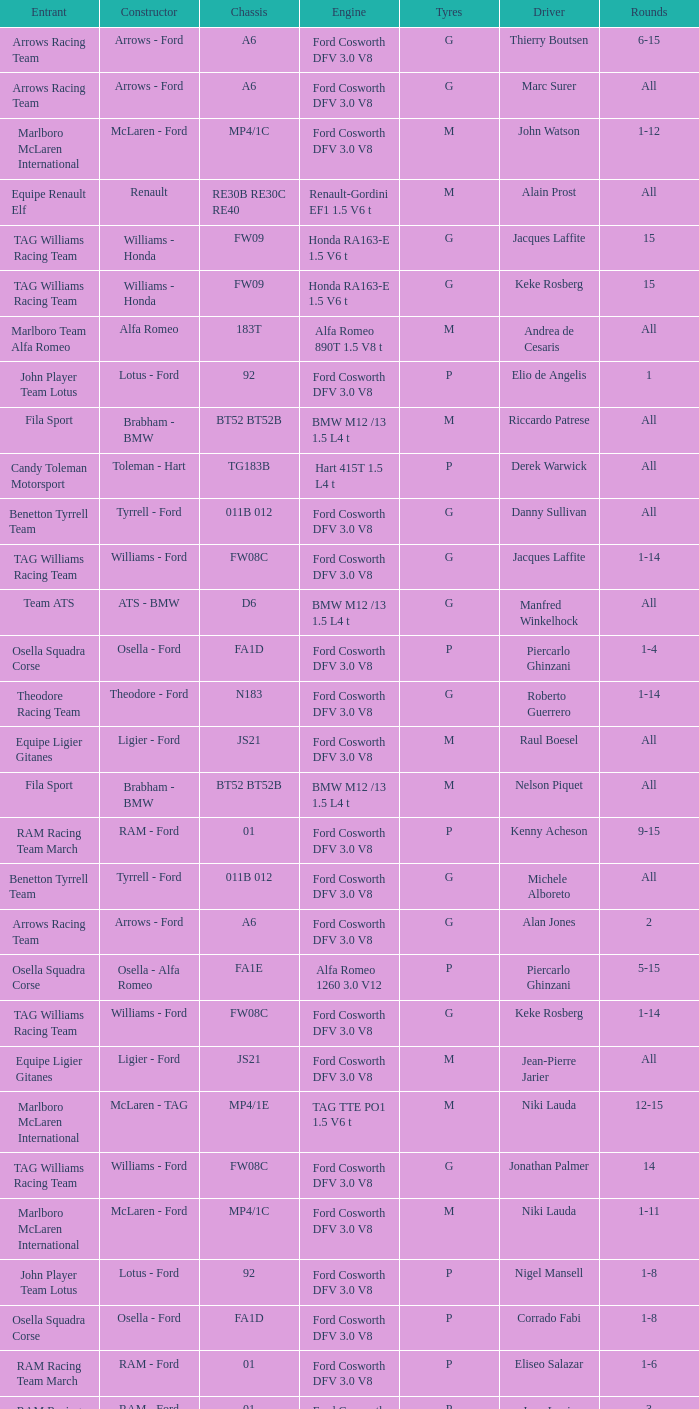Who is driver of the d6 chassis? Manfred Winkelhock. 